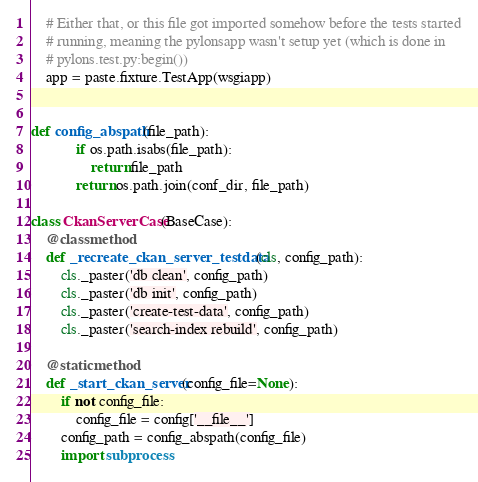Convert code to text. <code><loc_0><loc_0><loc_500><loc_500><_Python_>    # Either that, or this file got imported somehow before the tests started
    # running, meaning the pylonsapp wasn't setup yet (which is done in
    # pylons.test.py:begin())
    app = paste.fixture.TestApp(wsgiapp)


def config_abspath(file_path):
            if os.path.isabs(file_path):
                return file_path
            return os.path.join(conf_dir, file_path)

class CkanServerCase(BaseCase):
    @classmethod
    def _recreate_ckan_server_testdata(cls, config_path):
        cls._paster('db clean', config_path)
        cls._paster('db init', config_path)
        cls._paster('create-test-data', config_path)
        cls._paster('search-index rebuild', config_path)

    @staticmethod
    def _start_ckan_server(config_file=None):
        if not config_file:
            config_file = config['__file__']
        config_path = config_abspath(config_file)
        import subprocess</code> 